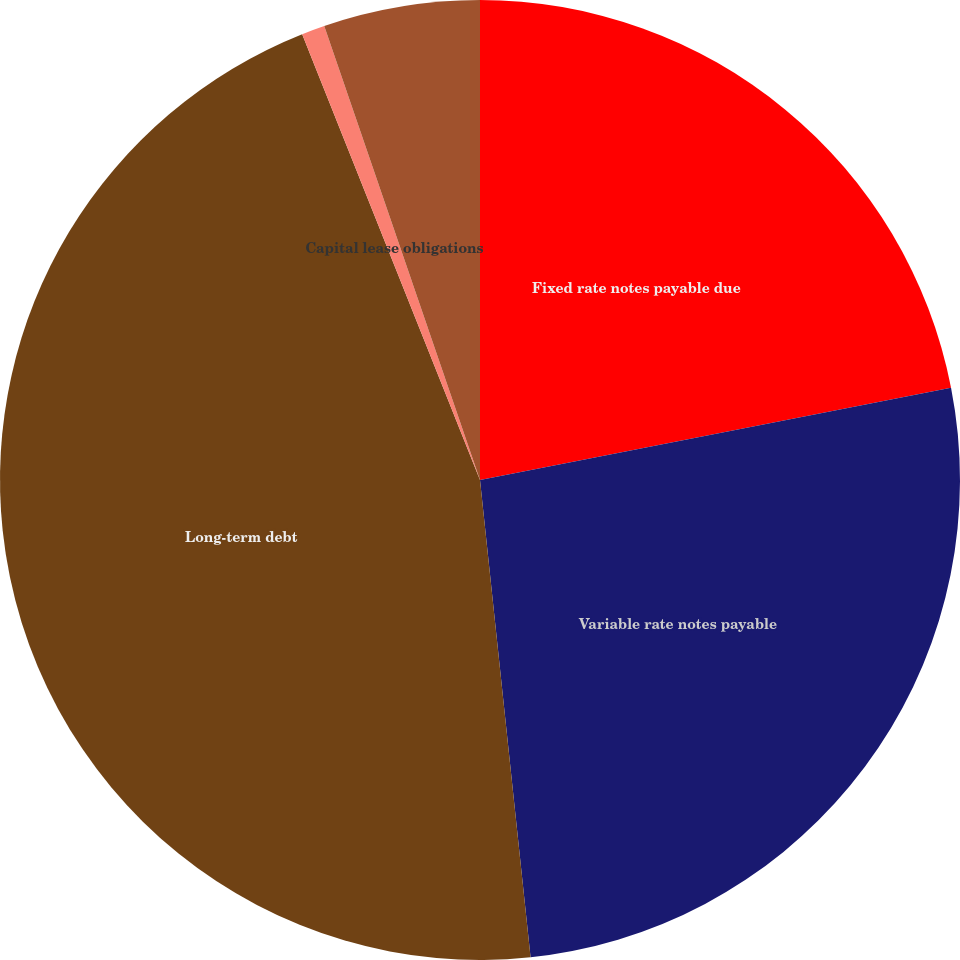Convert chart. <chart><loc_0><loc_0><loc_500><loc_500><pie_chart><fcel>Fixed rate notes payable due<fcel>Variable rate notes payable<fcel>Long-term debt<fcel>Capital lease obligations<fcel>Less current portion<nl><fcel>21.92%<fcel>26.4%<fcel>45.64%<fcel>0.78%<fcel>5.26%<nl></chart> 